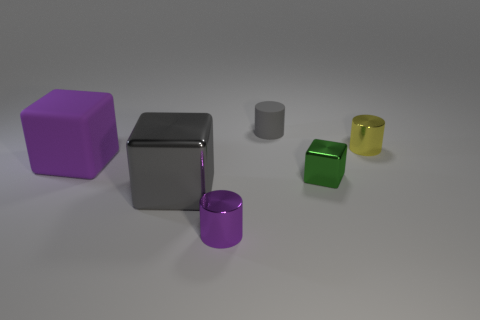Subtract all small green metallic blocks. How many blocks are left? 2 Subtract all gray cubes. How many cubes are left? 2 Add 3 purple metallic cylinders. How many objects exist? 9 Subtract 1 cubes. How many cubes are left? 2 Subtract all yellow cubes. Subtract all brown cylinders. How many cubes are left? 3 Subtract all gray cylinders. Subtract all small purple metallic cylinders. How many objects are left? 4 Add 1 matte blocks. How many matte blocks are left? 2 Add 1 tiny brown matte things. How many tiny brown matte things exist? 1 Subtract 0 green cylinders. How many objects are left? 6 